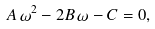Convert formula to latex. <formula><loc_0><loc_0><loc_500><loc_500>A \, \omega ^ { 2 } - 2 B \, \omega - C = 0 ,</formula> 